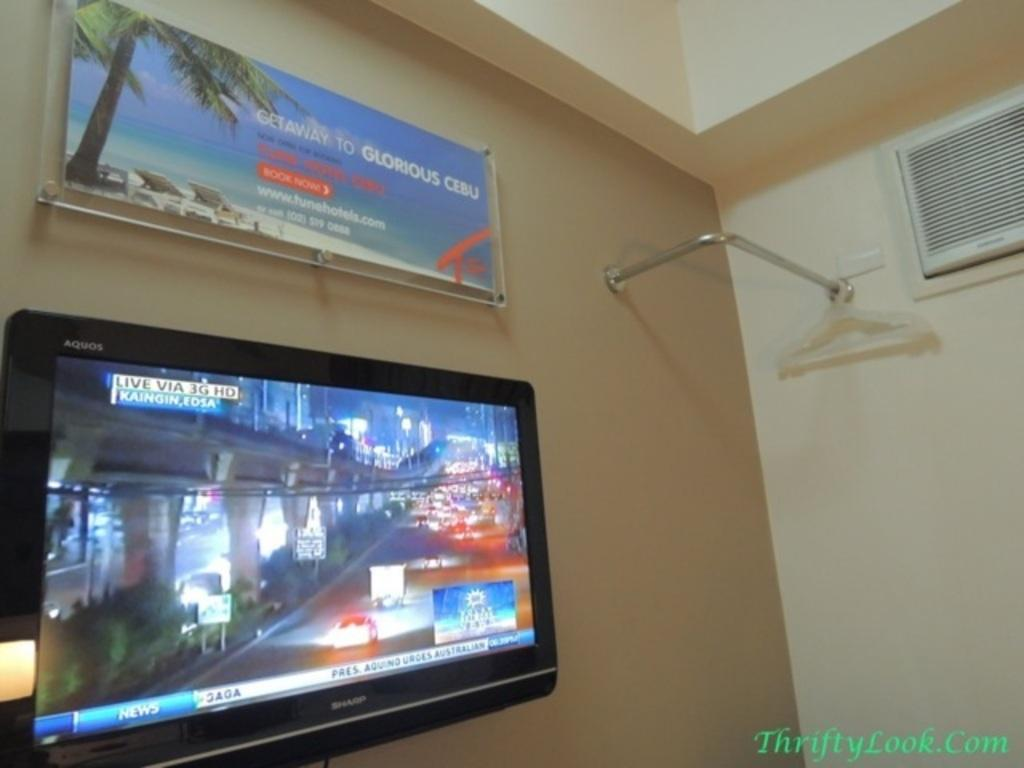<image>
Create a compact narrative representing the image presented. An advertisement for a getaway to Cebu hangs on a wall above a television. 